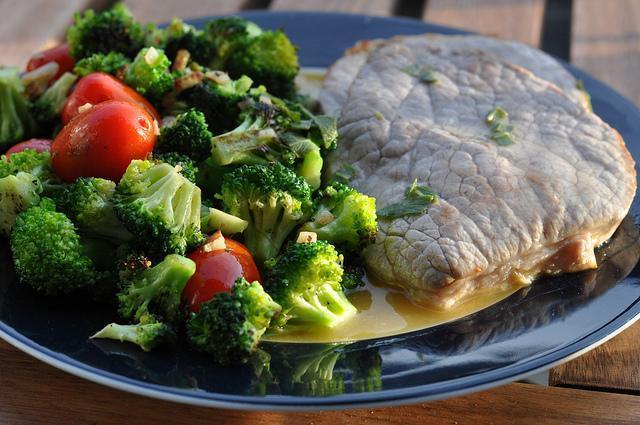What variety of tomato is on the plate?
Make your selection from the four choices given to correctly answer the question.
Options: Hot house, heirloom, roma, cherry. Cherry. 